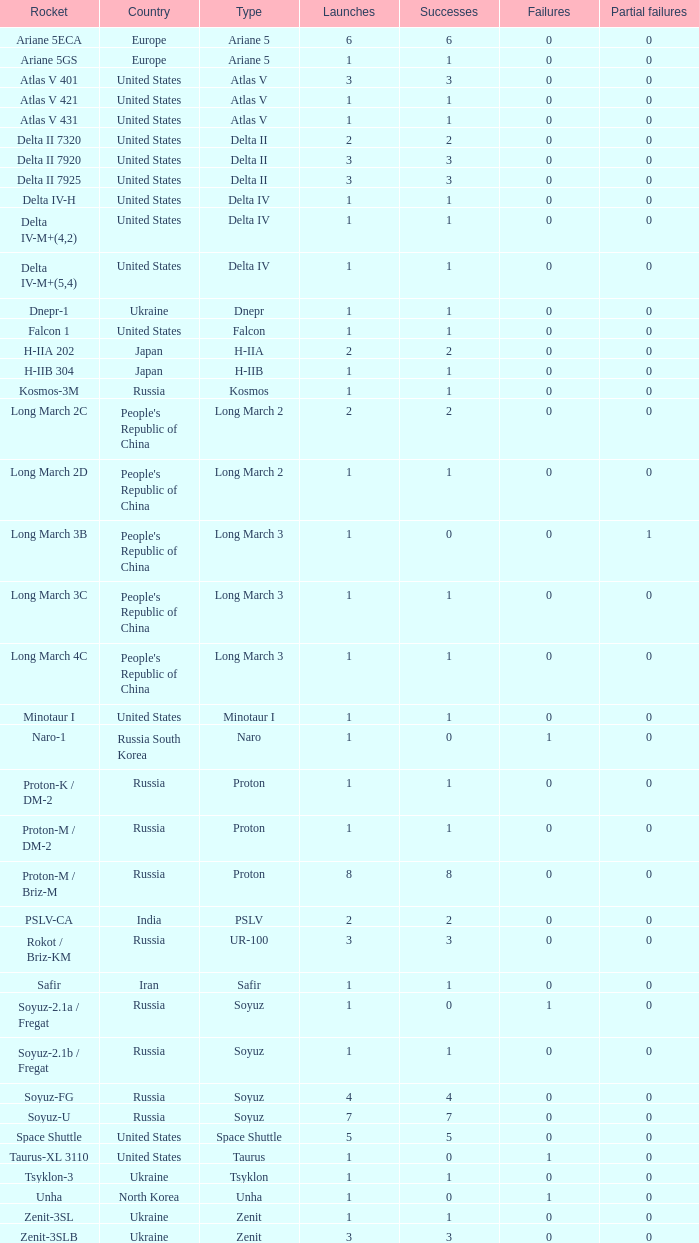How many successful launches have been achieved by russian rockets with over 3 launches, specifically of the soyuz and soyuz-u types? 1.0. 